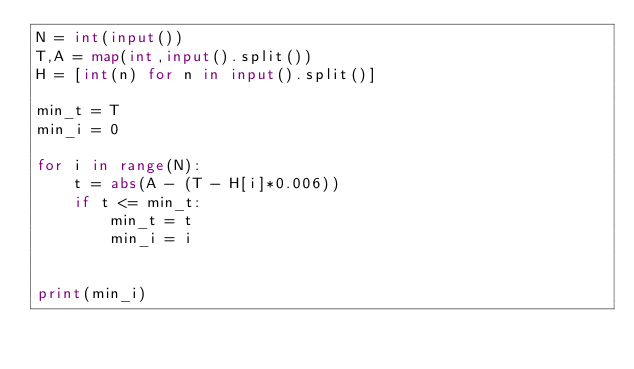<code> <loc_0><loc_0><loc_500><loc_500><_Python_>N = int(input())
T,A = map(int,input().split())
H = [int(n) for n in input().split()]

min_t = T
min_i = 0

for i in range(N):
    t = abs(A - (T - H[i]*0.006))
    if t <= min_t:
        min_t = t
        min_i = i


print(min_i)
</code> 